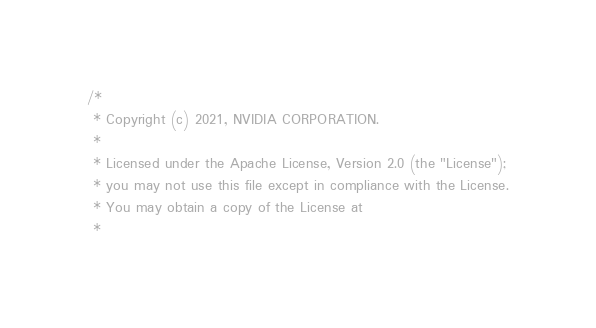<code> <loc_0><loc_0><loc_500><loc_500><_Cuda_>/*
 * Copyright (c) 2021, NVIDIA CORPORATION.
 *
 * Licensed under the Apache License, Version 2.0 (the "License");
 * you may not use this file except in compliance with the License.
 * You may obtain a copy of the License at
 *</code> 